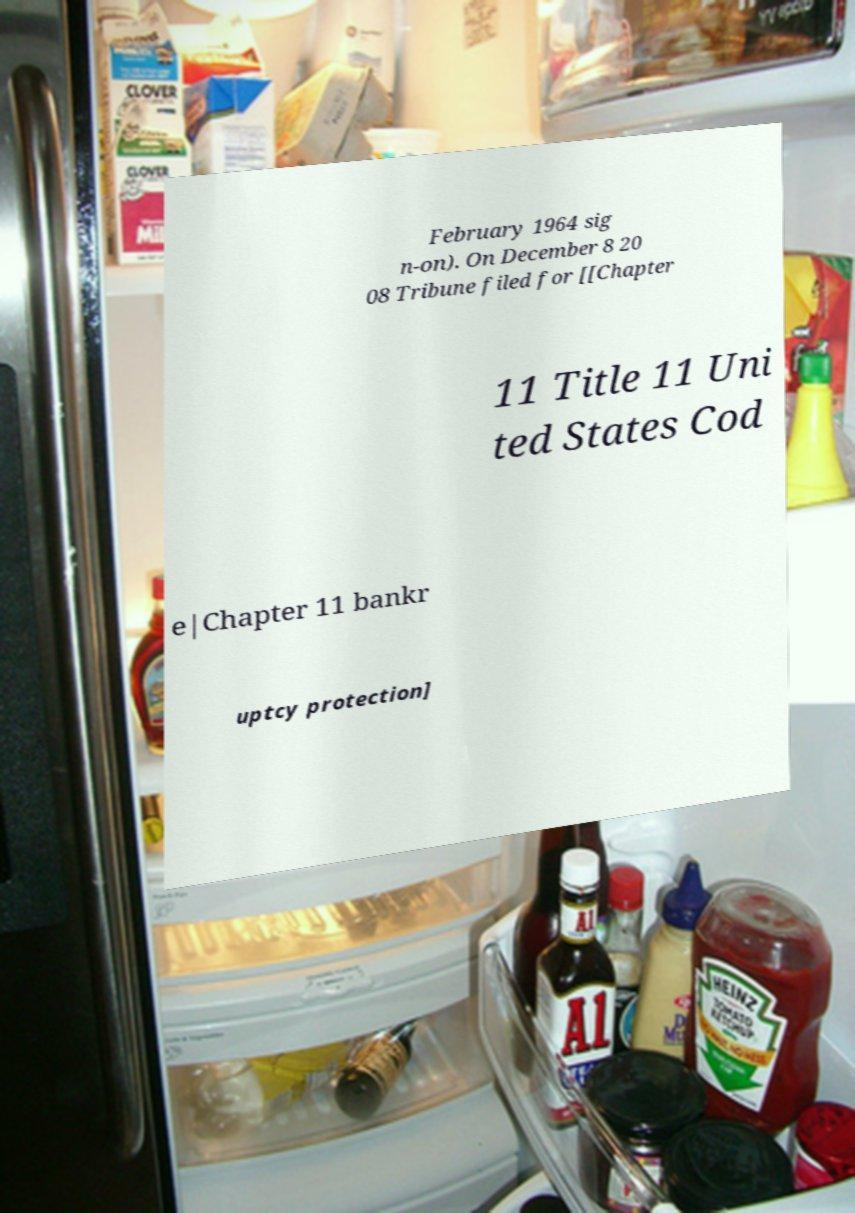Could you extract and type out the text from this image? February 1964 sig n-on). On December 8 20 08 Tribune filed for [[Chapter 11 Title 11 Uni ted States Cod e|Chapter 11 bankr uptcy protection] 